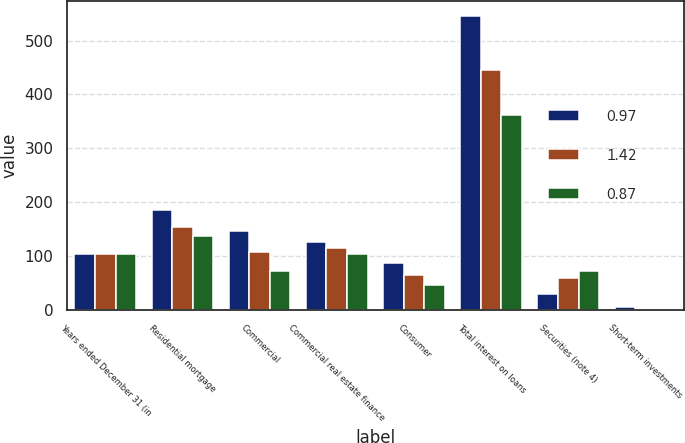Convert chart. <chart><loc_0><loc_0><loc_500><loc_500><stacked_bar_chart><ecel><fcel>Years ended December 31 (in<fcel>Residential mortgage<fcel>Commercial<fcel>Commercial real estate finance<fcel>Consumer<fcel>Total interest on loans<fcel>Securities (note 4)<fcel>Short-term investments<nl><fcel>0.97<fcel>104.9<fcel>185.2<fcel>146.5<fcel>126<fcel>88.3<fcel>546<fcel>30<fcel>5.3<nl><fcel>1.42<fcel>104.9<fcel>154.7<fcel>108.7<fcel>116.2<fcel>65.8<fcel>445.4<fcel>60<fcel>1.5<nl><fcel>0.87<fcel>104.9<fcel>137.7<fcel>73.3<fcel>104.9<fcel>46.7<fcel>362.6<fcel>72.4<fcel>2.2<nl></chart> 